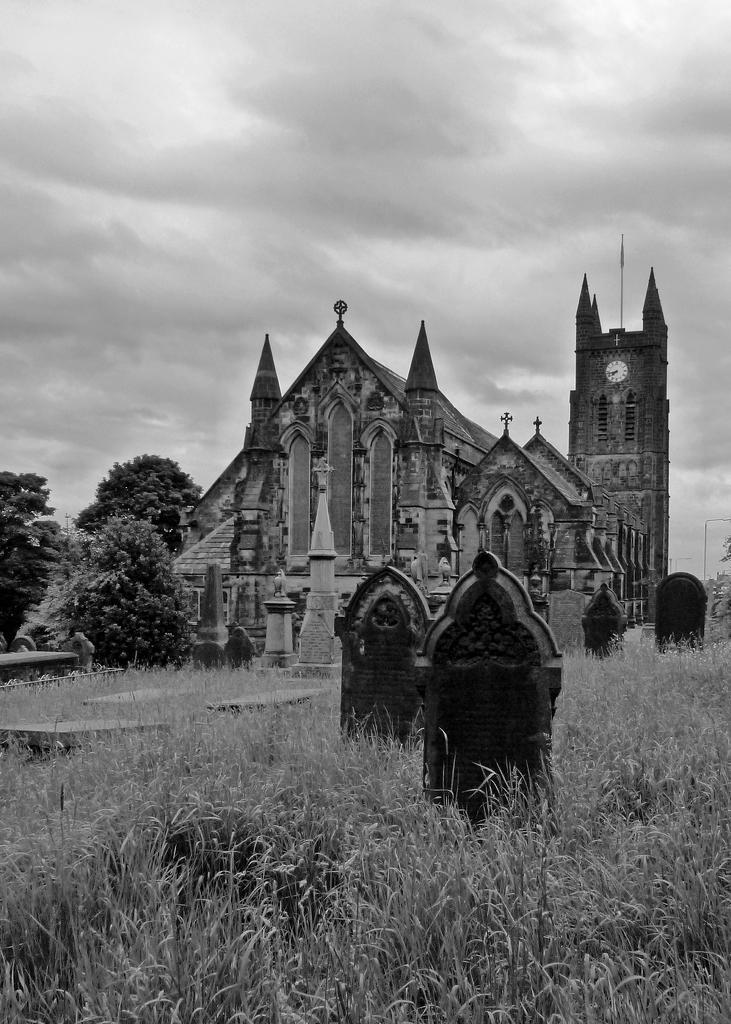Please provide a concise description of this image. In this picture we can observe a building and graveyard in front of the building. There is some grass on the ground. In the background there are trees and a sky with some clouds. This is a black and white image. 